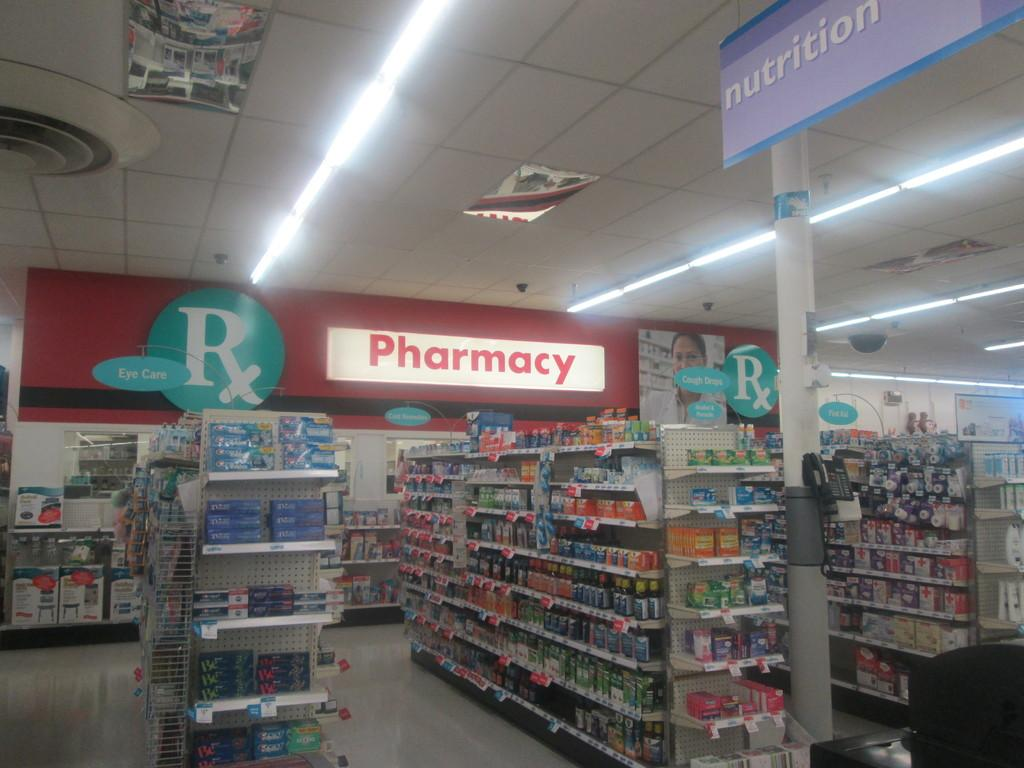Provide a one-sentence caption for the provided image. Shelves in a store containing Eye Care products sit in front of a large lit up sign that says Pharmacy. 